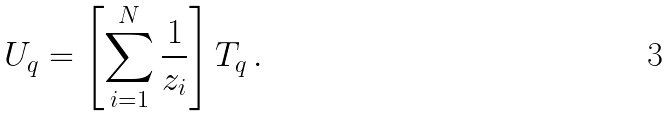Convert formula to latex. <formula><loc_0><loc_0><loc_500><loc_500>U _ { q } = \left [ \sum _ { i = 1 } ^ { N } \frac { 1 } { z _ { i } } \right ] T _ { q } \, .</formula> 